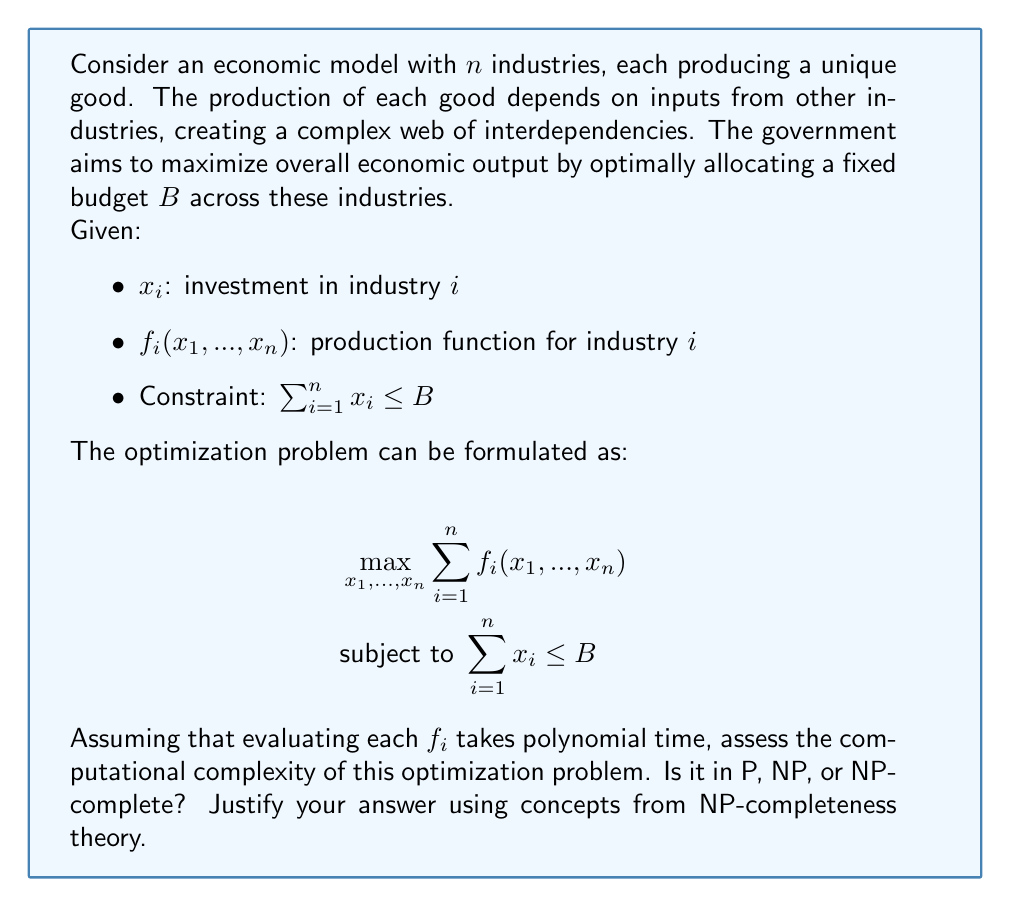Teach me how to tackle this problem. To assess the computational complexity of this optimization problem, we need to consider several factors:

1. Decision Problem Formulation:
   First, we need to reformulate the optimization problem as a decision problem:
   "Given a target value T, is there an allocation of investments $x_1, ..., x_n$ such that $\sum_{i=1}^n f_i(x_1, ..., x_n) \geq T$ and $\sum_{i=1}^n x_i \leq B$?"

2. Verification:
   Given a solution (i.e., a set of $x_i$ values), we can verify if it satisfies the constraints and achieves the target value T in polynomial time. This is because:
   a) Evaluating each $f_i$ takes polynomial time (given in the problem).
   b) Summing the outputs and comparing to T takes linear time.
   c) Checking the budget constraint takes linear time.
   Therefore, the problem is in NP.

3. Hardness:
   The problem can be shown to be at least as hard as the Knapsack problem, which is known to be NP-complete. We can reduce the Knapsack problem to our economic optimization problem:
   - Let each industry correspond to an item in the Knapsack problem.
   - Let $f_i(x_i) = v_i$ if $x_i \geq w_i$, and 0 otherwise, where $v_i$ and $w_i$ are the value and weight of item i in the Knapsack problem.
   - Set B equal to the Knapsack capacity.

   This reduction preserves the structure of the Knapsack problem while fitting into our economic model framework.

4. NP-completeness:
   Since the problem is in NP and we can reduce a known NP-complete problem (Knapsack) to it, our economic optimization problem is NP-complete.

5. Implications:
   Being NP-complete implies that there is no known polynomial-time algorithm to solve this problem optimally for all instances, unless P = NP. This means that as the number of industries (n) grows, the time required to find the optimal solution grows exponentially in the worst case.

6. Tractability:
   While the problem is NP-complete and thus intractable for large instances, it may still be solvable for small to medium-sized economic models using techniques such as:
   a) Dynamic programming (for certain types of production functions)
   b) Branch and bound algorithms
   c) Approximation algorithms that provide near-optimal solutions in polynomial time

In practice, economists often use heuristics or approximation algorithms to tackle such complex optimization problems, trading off some degree of optimality for computational feasibility.
Answer: NP-complete 